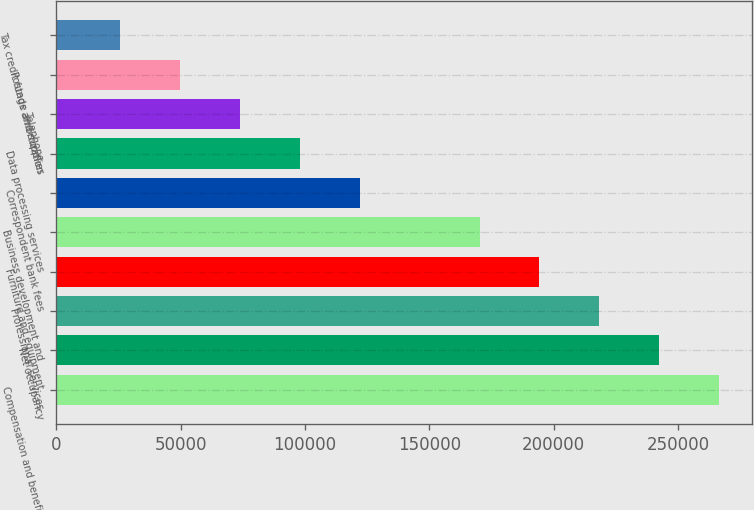Convert chart to OTSL. <chart><loc_0><loc_0><loc_500><loc_500><bar_chart><fcel>Compensation and benefits<fcel>Net occupancy<fcel>Professional services<fcel>Furniture and equipment<fcel>Business development and<fcel>Correspondent bank fees<fcel>Data processing services<fcel>Telephone<fcel>Postage and supplies<fcel>Tax credit funds amortization<nl><fcel>266580<fcel>242486<fcel>218392<fcel>194299<fcel>170205<fcel>122018<fcel>97923.8<fcel>73830.1<fcel>49736.4<fcel>25642.7<nl></chart> 